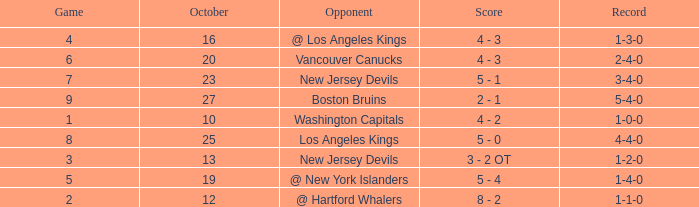What was the average game with a record of 4-4-0? 8.0. 